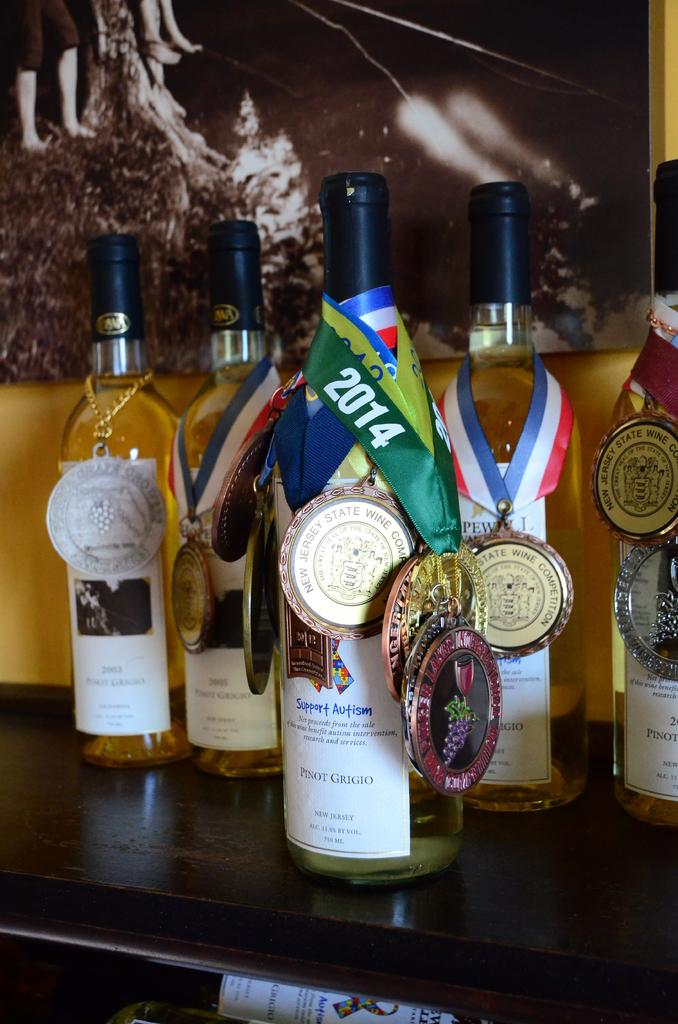Provide a one-sentence caption for the provided image. A bottle of Pinot Grigio that supports Autism. 